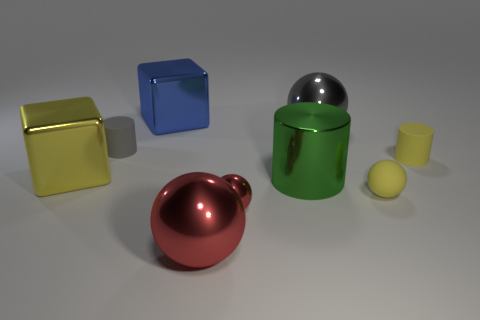Subtract all large gray balls. How many balls are left? 3 Subtract all spheres. How many objects are left? 5 Subtract 1 cylinders. How many cylinders are left? 2 Subtract all purple spheres. Subtract all blue cylinders. How many spheres are left? 4 Subtract all yellow cylinders. How many red balls are left? 2 Subtract all large blue cylinders. Subtract all yellow blocks. How many objects are left? 8 Add 6 cylinders. How many cylinders are left? 9 Add 2 purple rubber cubes. How many purple rubber cubes exist? 2 Add 1 small blue metallic objects. How many objects exist? 10 Subtract all gray balls. How many balls are left? 3 